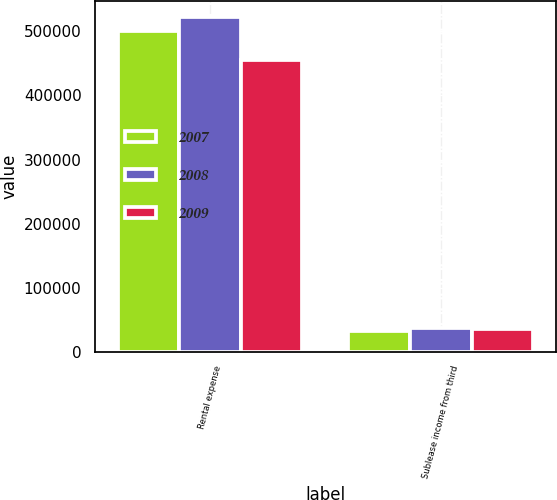<chart> <loc_0><loc_0><loc_500><loc_500><stacked_bar_chart><ecel><fcel>Rental expense<fcel>Sublease income from third<nl><fcel>2007<fcel>500949<fcel>33179<nl><fcel>2008<fcel>521880<fcel>37625<nl><fcel>2009<fcel>455212<fcel>35147<nl></chart> 